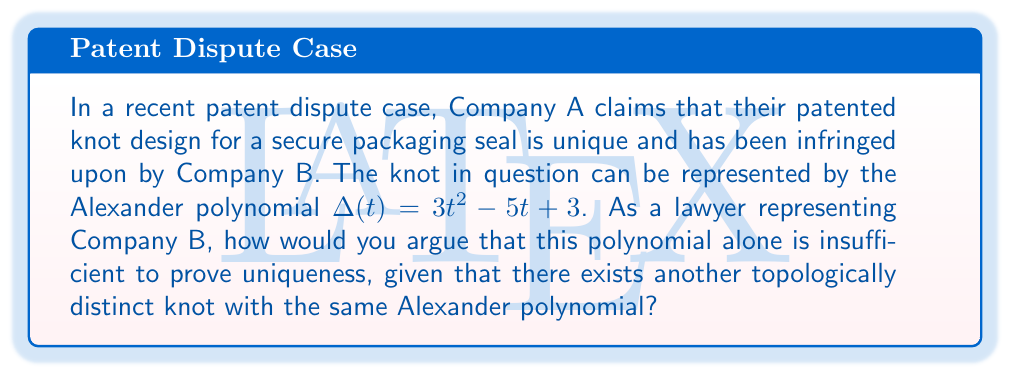Give your solution to this math problem. 1. Understand the Alexander polynomial:
   The Alexander polynomial is a knot invariant, meaning it remains unchanged under ambient isotopy (continuous deformation without cutting or gluing).

2. Analyze the given polynomial:
   $\Delta(t) = 3t^2 - 5t + 3$

3. Recognize the limitations of the Alexander polynomial:
   While the Alexander polynomial is a powerful tool in distinguishing many knots, it is not a complete invariant. This means that two different knots can have the same Alexander polynomial.

4. Identify a counterexample:
   The knot 5_2 (using the Alexander-Briggs notation) and the granny knot (3_1 # 3_1) both have the Alexander polynomial $\Delta(t) = t^2 - t + 1$.

5. Legal argument construction:
   a) Emphasize that the Alexander polynomial alone is not sufficient to prove uniqueness.
   b) Highlight that different knots can share the same Alexander polynomial.
   c) Argue that additional invariants or a more comprehensive analysis is necessary to establish uniqueness.
   d) Suggest that Company A's claim of uniqueness based solely on the Alexander polynomial is not legally sound.

6. Propose alternative methods:
   Recommend the use of stronger invariants or combinations of invariants, such as:
   - Jones polynomial
   - HOMFLY polynomial
   - Khovanov homology

7. Conclude:
   Assert that without additional evidence or more comprehensive knot invariants, Company A cannot definitively prove that their knot design is unique and has been infringed upon.
Answer: The Alexander polynomial alone is insufficient to prove knot uniqueness in patent disputes. 